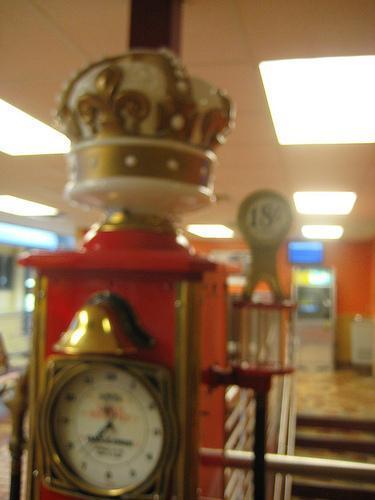How many clocks?
Give a very brief answer. 1. How many white dots on crown?
Give a very brief answer. 5. How many lights?
Give a very brief answer. 6. 